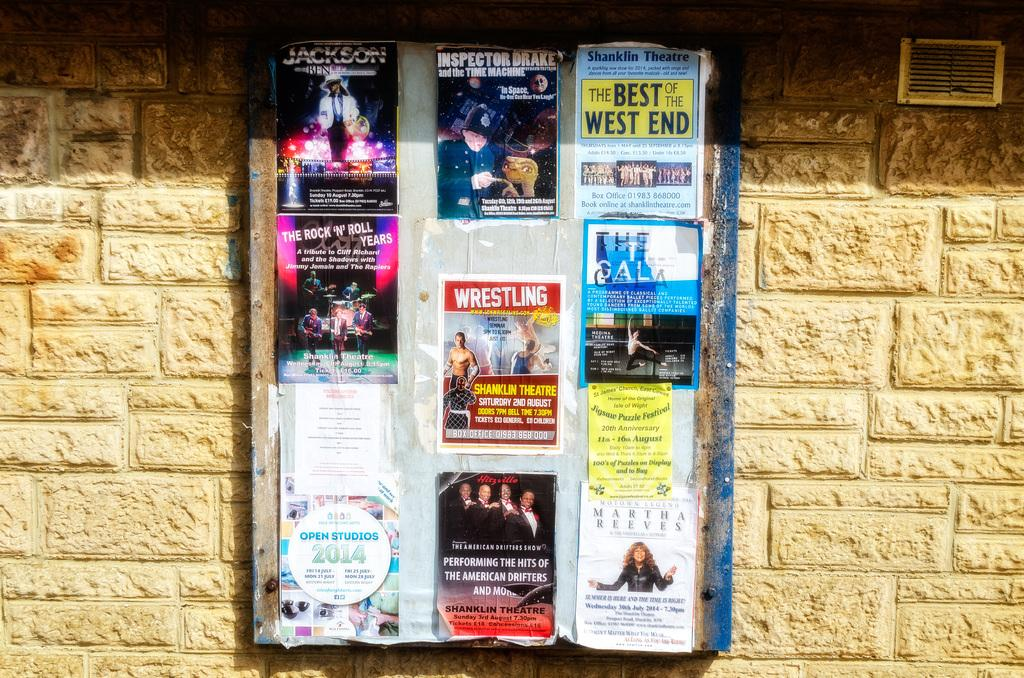<image>
Describe the image concisely. Theater advertisments including The Best of the West End 